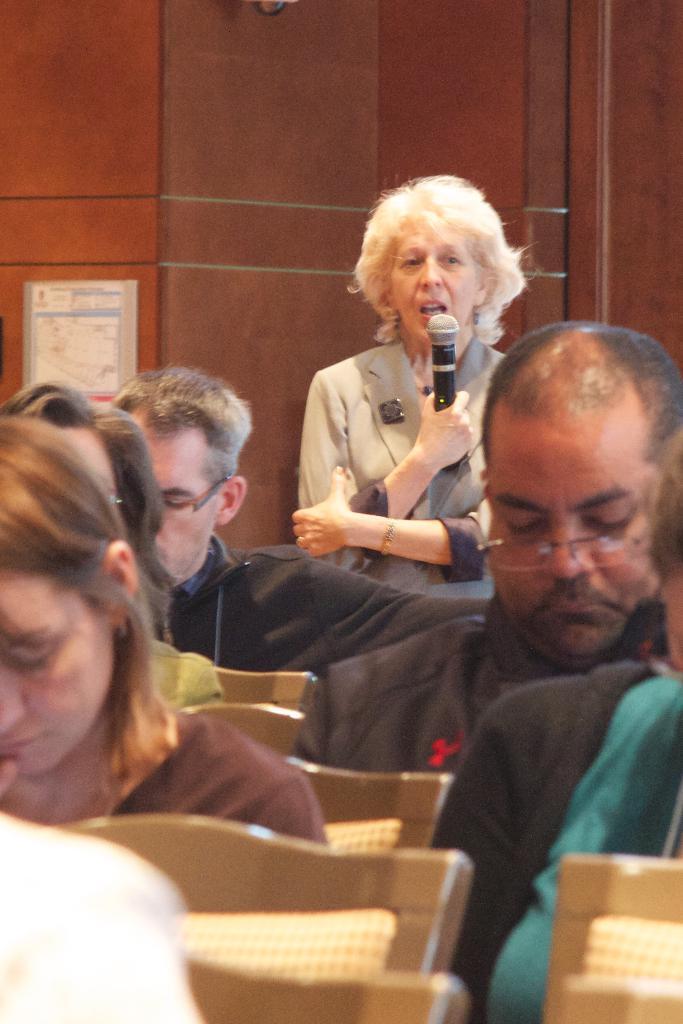Could you give a brief overview of what you see in this image? This image is taken inside a room. In the left side of the image few people are sitting on a chairs. In the right side of the image a man is sitting on a chair. In the middle of the image a woman is standing with holding a mic in her hand. At the background there is a wall. 